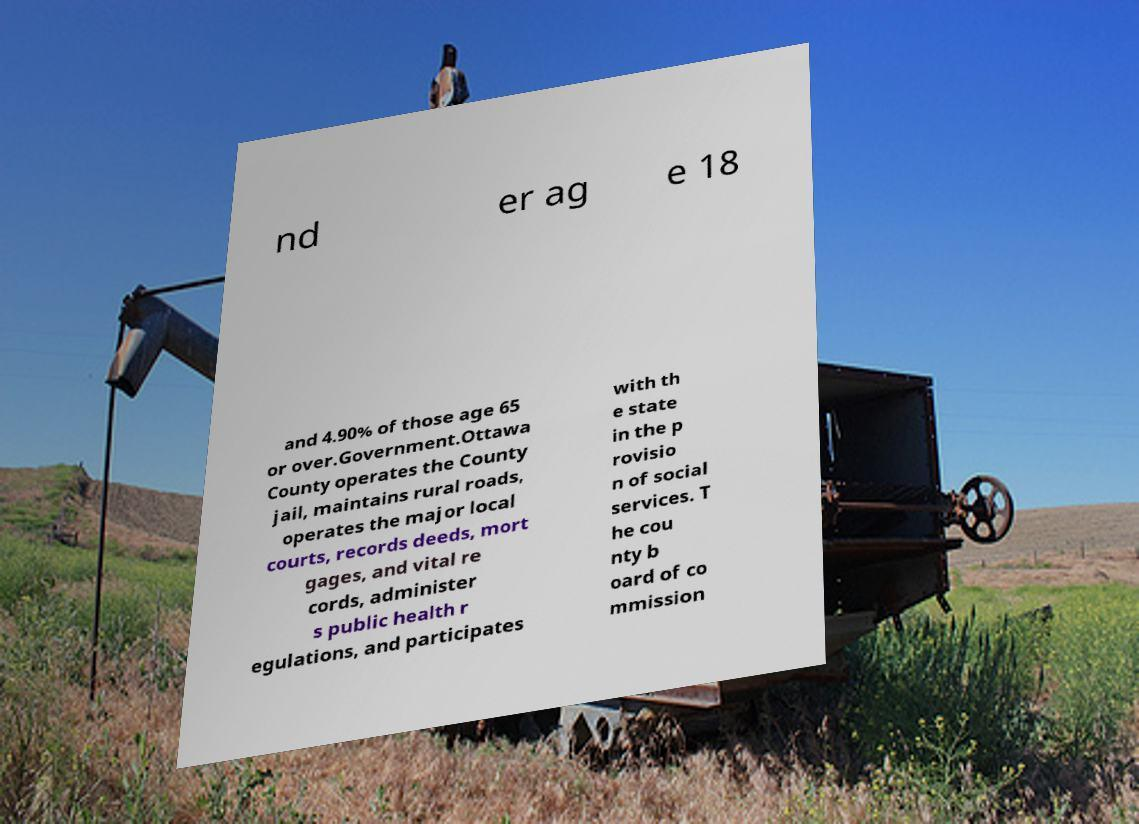Can you read and provide the text displayed in the image?This photo seems to have some interesting text. Can you extract and type it out for me? nd er ag e 18 and 4.90% of those age 65 or over.Government.Ottawa County operates the County jail, maintains rural roads, operates the major local courts, records deeds, mort gages, and vital re cords, administer s public health r egulations, and participates with th e state in the p rovisio n of social services. T he cou nty b oard of co mmission 